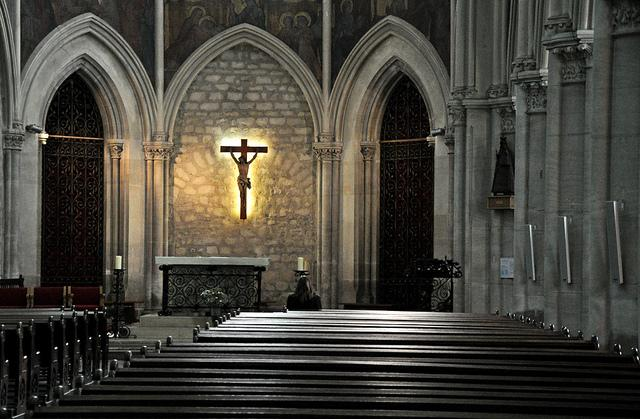How might you be considered if you set a fire here? evil 